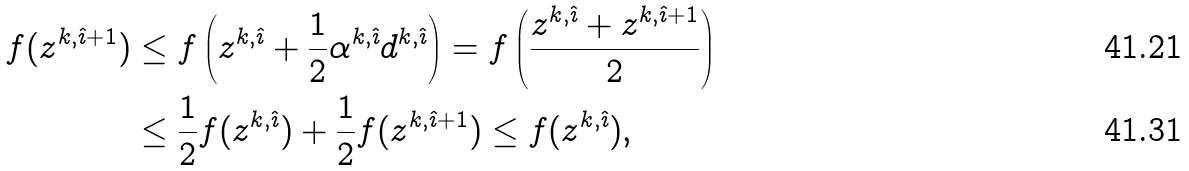Convert formula to latex. <formula><loc_0><loc_0><loc_500><loc_500>f ( z ^ { k , \hat { \imath } + 1 } ) & \leq f \left ( z ^ { k , \hat { \imath } } + \frac { 1 } { 2 } \alpha ^ { k , \hat { \imath } } d ^ { k , \hat { \imath } } \right ) = f \left ( \frac { z ^ { k , \hat { \imath } } + z ^ { k , \hat { \imath } + 1 } } 2 \right ) \\ & \leq \frac { 1 } { 2 } f ( z ^ { k , \hat { \imath } } ) + \frac { 1 } { 2 } f ( z ^ { k , \hat { \imath } + 1 } ) \leq f ( z ^ { k , \hat { \imath } } ) ,</formula> 